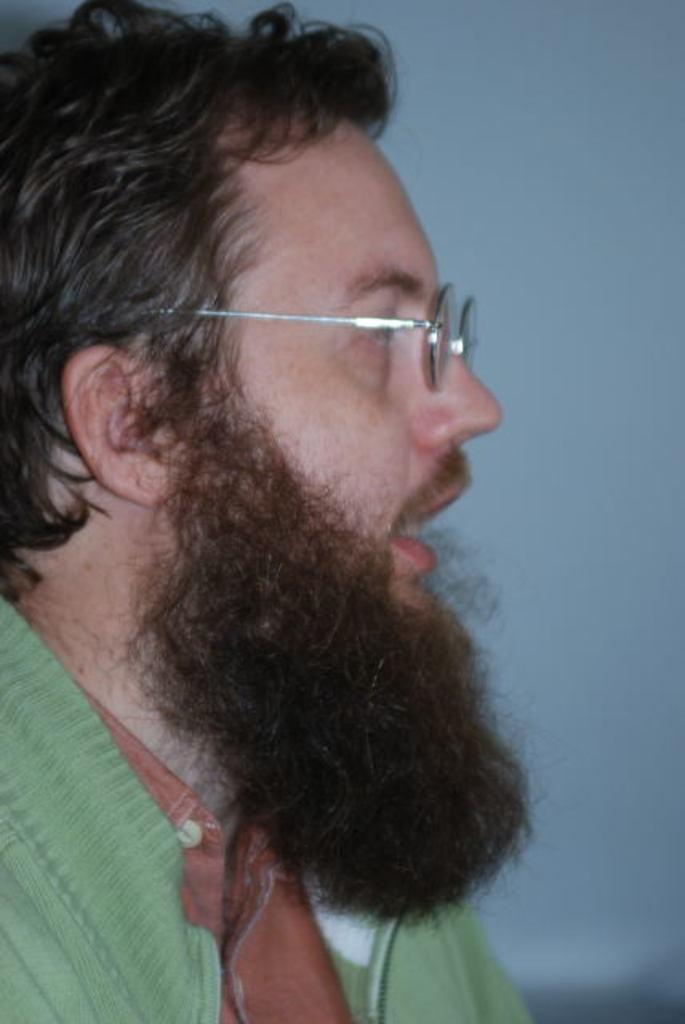What color is the dress worn by the person in the image? The person in the image is wearing a brown and green color dress. Can you describe the background of the image? The background of the image is blue and white in color. What type of noise can be heard coming from the development in the image? There is no reference to a development or any noise in the image, so it's not possible to determine what, if any, noise might be heard. 